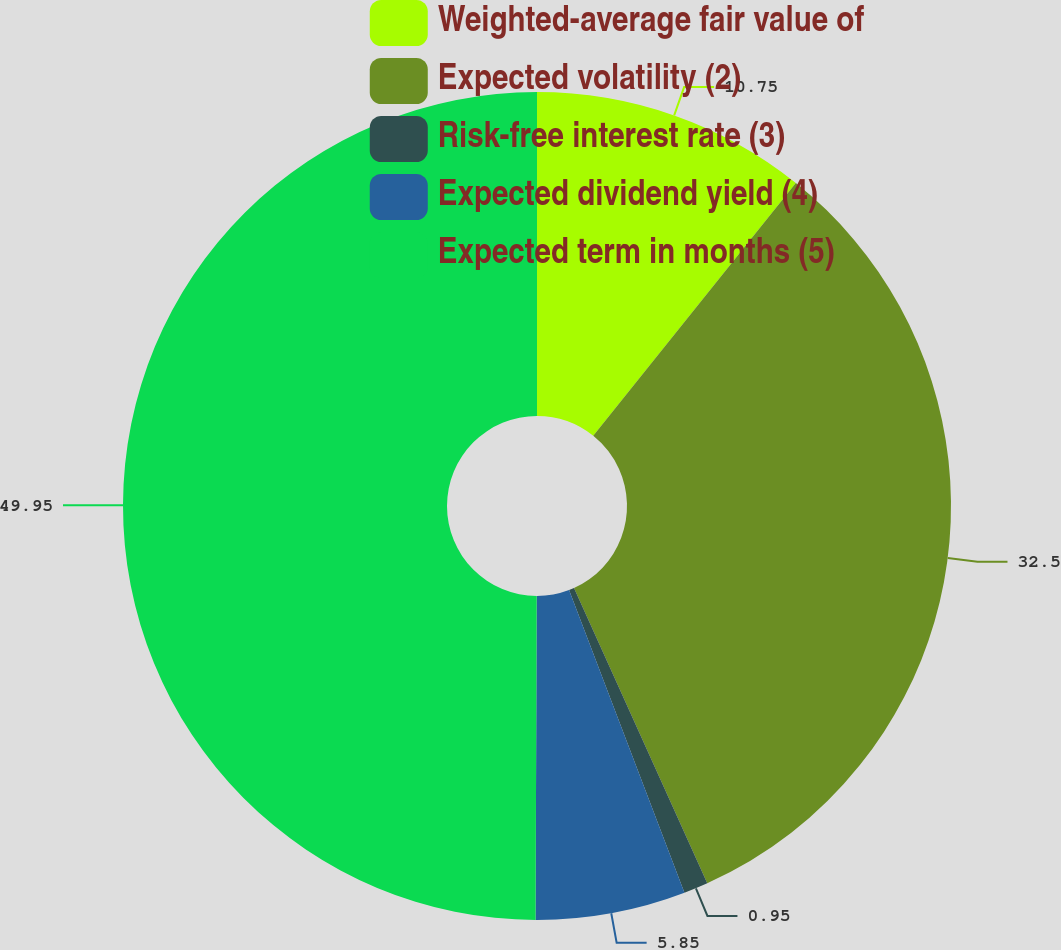<chart> <loc_0><loc_0><loc_500><loc_500><pie_chart><fcel>Weighted-average fair value of<fcel>Expected volatility (2)<fcel>Risk-free interest rate (3)<fcel>Expected dividend yield (4)<fcel>Expected term in months (5)<nl><fcel>10.75%<fcel>32.5%<fcel>0.95%<fcel>5.85%<fcel>49.94%<nl></chart> 